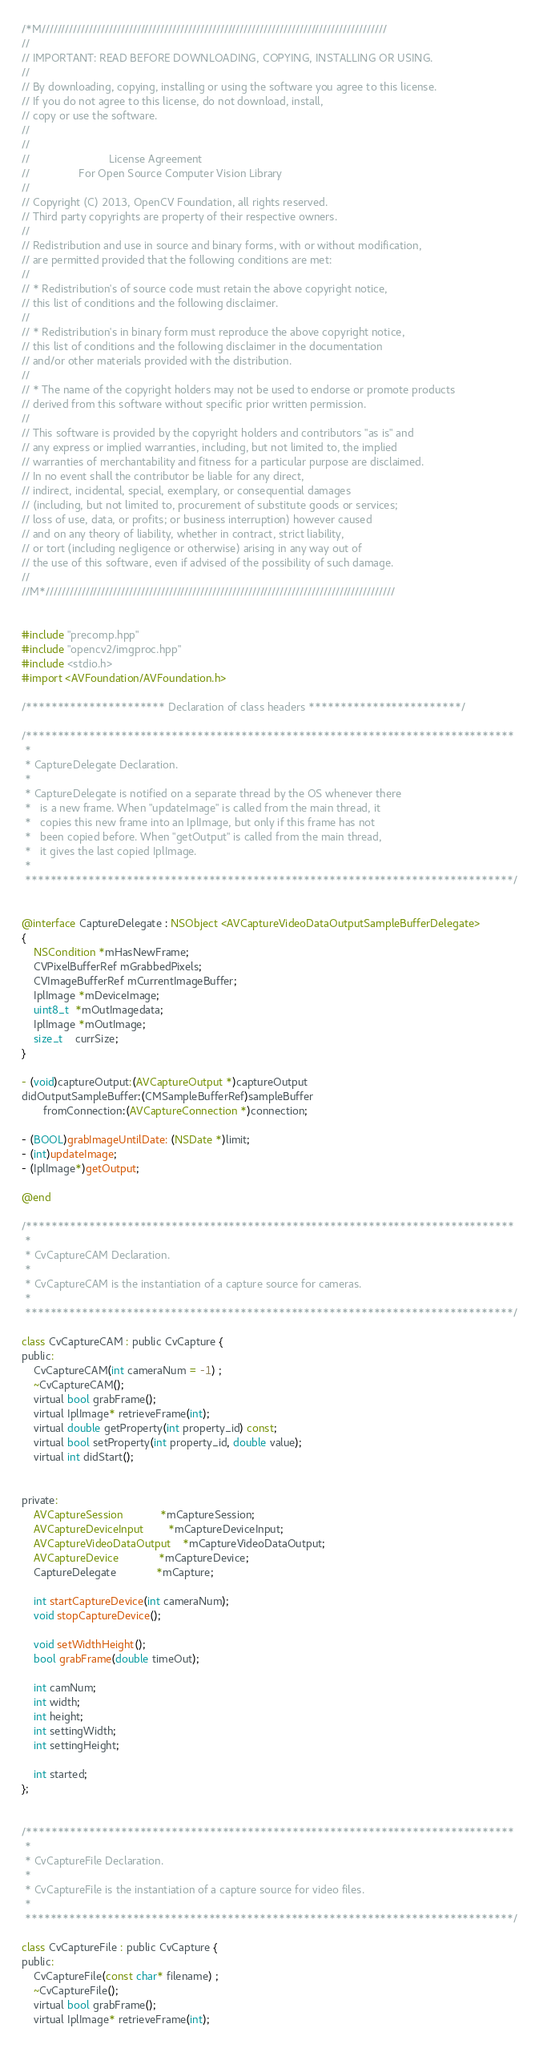Convert code to text. <code><loc_0><loc_0><loc_500><loc_500><_ObjectiveC_>/*M///////////////////////////////////////////////////////////////////////////////////////
//
// IMPORTANT: READ BEFORE DOWNLOADING, COPYING, INSTALLING OR USING.
//
// By downloading, copying, installing or using the software you agree to this license.
// If you do not agree to this license, do not download, install,
// copy or use the software.
//
//
//                          License Agreement
//                For Open Source Computer Vision Library
//
// Copyright (C) 2013, OpenCV Foundation, all rights reserved.
// Third party copyrights are property of their respective owners.
//
// Redistribution and use in source and binary forms, with or without modification,
// are permitted provided that the following conditions are met:
//
// * Redistribution's of source code must retain the above copyright notice,
// this list of conditions and the following disclaimer.
//
// * Redistribution's in binary form must reproduce the above copyright notice,
// this list of conditions and the following disclaimer in the documentation
// and/or other materials provided with the distribution.
//
// * The name of the copyright holders may not be used to endorse or promote products
// derived from this software without specific prior written permission.
//
// This software is provided by the copyright holders and contributors "as is" and
// any express or implied warranties, including, but not limited to, the implied
// warranties of merchantability and fitness for a particular purpose are disclaimed.
// In no event shall the contributor be liable for any direct,
// indirect, incidental, special, exemplary, or consequential damages
// (including, but not limited to, procurement of substitute goods or services;
// loss of use, data, or profits; or business interruption) however caused
// and on any theory of liability, whether in contract, strict liability,
// or tort (including negligence or otherwise) arising in any way out of
// the use of this software, even if advised of the possibility of such damage.
//
//M*////////////////////////////////////////////////////////////////////////////////////////


#include "precomp.hpp"
#include "opencv2/imgproc.hpp"
#include <stdio.h>
#import <AVFoundation/AVFoundation.h>

/********************** Declaration of class headers ************************/

/*****************************************************************************
 *
 * CaptureDelegate Declaration.
 *
 * CaptureDelegate is notified on a separate thread by the OS whenever there
 *   is a new frame. When "updateImage" is called from the main thread, it
 *   copies this new frame into an IplImage, but only if this frame has not
 *   been copied before. When "getOutput" is called from the main thread,
 *   it gives the last copied IplImage.
 *
 *****************************************************************************/


@interface CaptureDelegate : NSObject <AVCaptureVideoDataOutputSampleBufferDelegate>
{
    NSCondition *mHasNewFrame;
    CVPixelBufferRef mGrabbedPixels;
    CVImageBufferRef mCurrentImageBuffer;
    IplImage *mDeviceImage;
    uint8_t  *mOutImagedata;
    IplImage *mOutImage;
    size_t    currSize;
}

- (void)captureOutput:(AVCaptureOutput *)captureOutput
didOutputSampleBuffer:(CMSampleBufferRef)sampleBuffer
       fromConnection:(AVCaptureConnection *)connection;

- (BOOL)grabImageUntilDate: (NSDate *)limit;
- (int)updateImage;
- (IplImage*)getOutput;

@end

/*****************************************************************************
 *
 * CvCaptureCAM Declaration.
 *
 * CvCaptureCAM is the instantiation of a capture source for cameras.
 *
 *****************************************************************************/

class CvCaptureCAM : public CvCapture {
public:
    CvCaptureCAM(int cameraNum = -1) ;
    ~CvCaptureCAM();
    virtual bool grabFrame();
    virtual IplImage* retrieveFrame(int);
    virtual double getProperty(int property_id) const;
    virtual bool setProperty(int property_id, double value);
    virtual int didStart();


private:
    AVCaptureSession            *mCaptureSession;
    AVCaptureDeviceInput        *mCaptureDeviceInput;
    AVCaptureVideoDataOutput    *mCaptureVideoDataOutput;
    AVCaptureDevice             *mCaptureDevice;
    CaptureDelegate             *mCapture;

    int startCaptureDevice(int cameraNum);
    void stopCaptureDevice();

    void setWidthHeight();
    bool grabFrame(double timeOut);

    int camNum;
    int width;
    int height;
    int settingWidth;
    int settingHeight;

    int started;
};


/*****************************************************************************
 *
 * CvCaptureFile Declaration.
 *
 * CvCaptureFile is the instantiation of a capture source for video files.
 *
 *****************************************************************************/

class CvCaptureFile : public CvCapture {
public:
    CvCaptureFile(const char* filename) ;
    ~CvCaptureFile();
    virtual bool grabFrame();
    virtual IplImage* retrieveFrame(int);</code> 